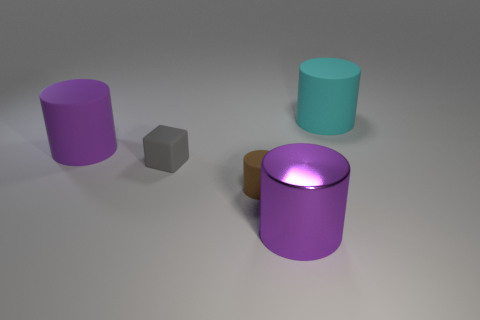Can you describe the lighting in the image? Certainly! The image exhibits soft and diffuse lighting with gentle shadows, suggesting an indirect light source. The light appears to come from above as evidenced by the soft shadows under the objects, giving the scene a calm and even tone. 